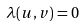Convert formula to latex. <formula><loc_0><loc_0><loc_500><loc_500>\lambda ( u , v ) = 0</formula> 